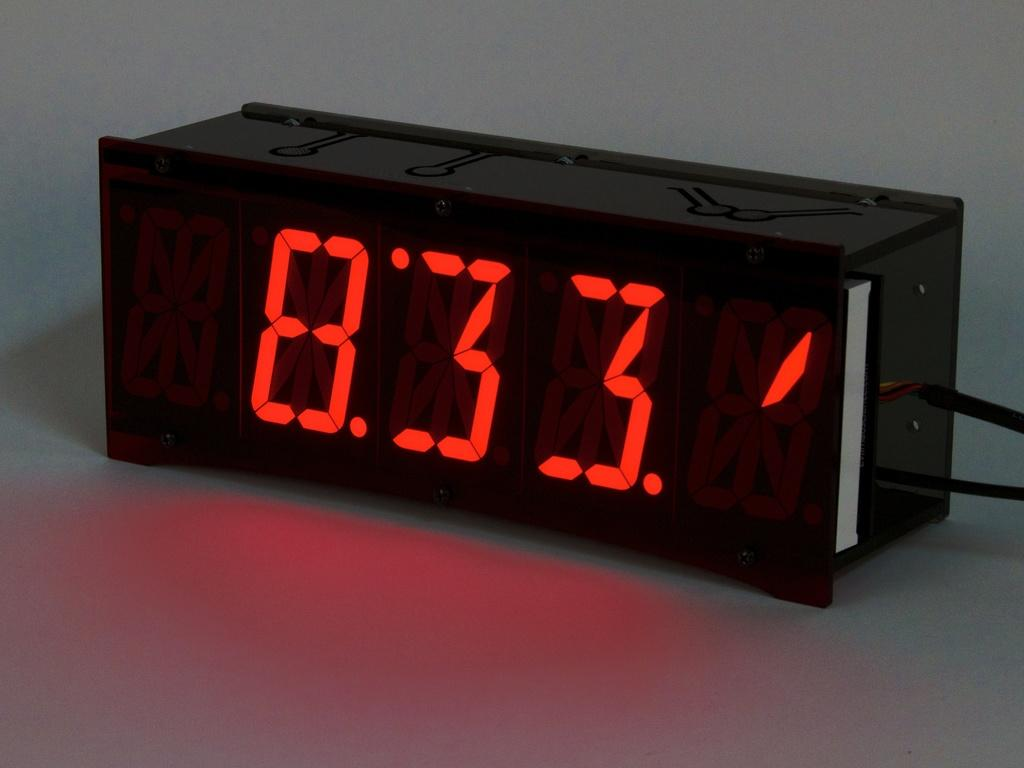<image>
Render a clear and concise summary of the photo. A black digital clock with the time reading 8:33 